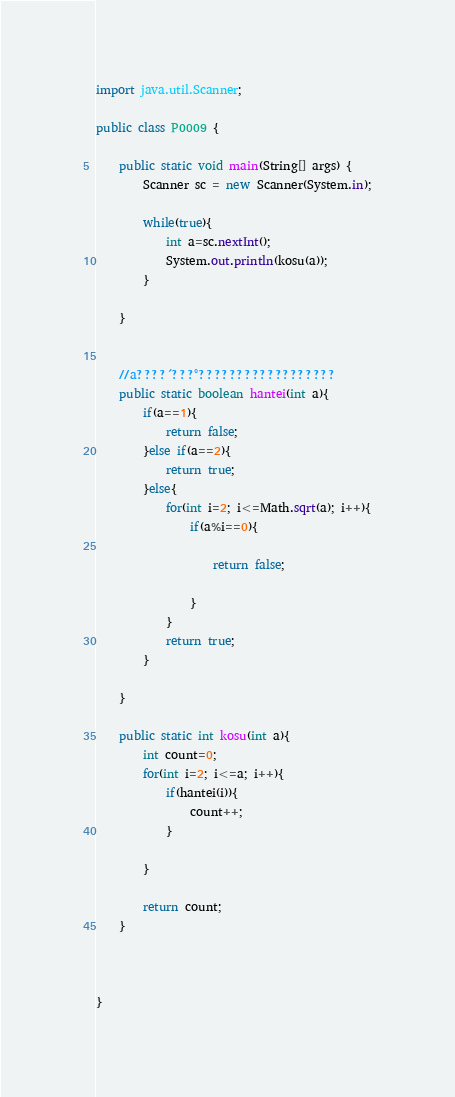Convert code to text. <code><loc_0><loc_0><loc_500><loc_500><_Java_>import java.util.Scanner;

public class P0009 {

	public static void main(String[] args) {
		Scanner sc = new Scanner(System.in);

		while(true){
			int a=sc.nextInt();
			System.out.println(kosu(a));
		}
		
	}


	//a????´???°??????????????????
	public static boolean hantei(int a){
		if(a==1){
			return false;
		}else if(a==2){
			return true;
		}else{
			for(int i=2; i<=Math.sqrt(a); i++){
				if(a%i==0){

					return false;

				}
			}
			return true;
		}

	}

	public static int kosu(int a){
		int count=0;
		for(int i=2; i<=a; i++){
			if(hantei(i)){
				count++;
			}

		}

		return count;
	}



}</code> 